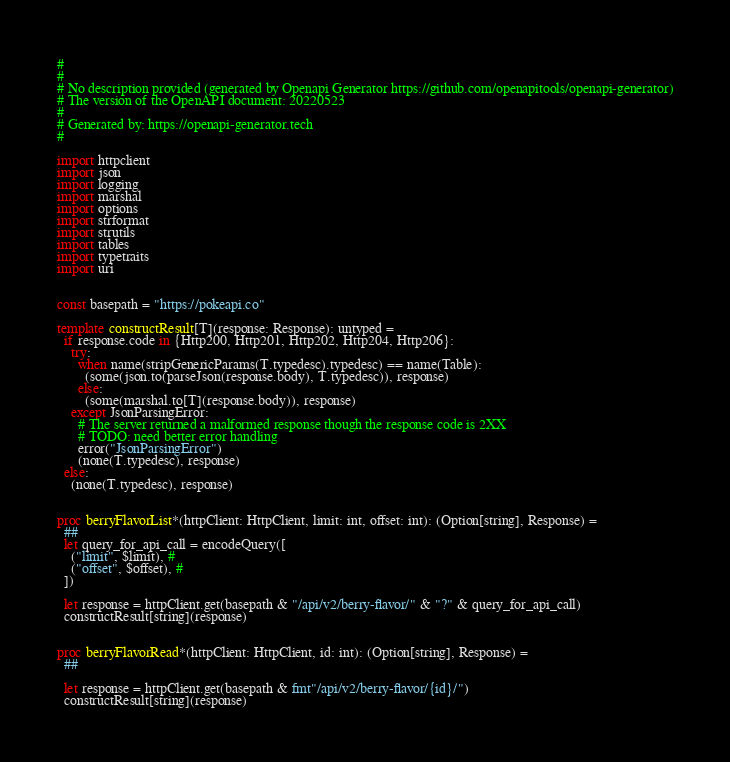Convert code to text. <code><loc_0><loc_0><loc_500><loc_500><_Nim_>#
# 
# No description provided (generated by Openapi Generator https://github.com/openapitools/openapi-generator)
# The version of the OpenAPI document: 20220523
# 
# Generated by: https://openapi-generator.tech
#

import httpclient
import json
import logging
import marshal
import options
import strformat
import strutils
import tables
import typetraits
import uri


const basepath = "https://pokeapi.co"

template constructResult[T](response: Response): untyped =
  if response.code in {Http200, Http201, Http202, Http204, Http206}:
    try:
      when name(stripGenericParams(T.typedesc).typedesc) == name(Table):
        (some(json.to(parseJson(response.body), T.typedesc)), response)
      else:
        (some(marshal.to[T](response.body)), response)
    except JsonParsingError:
      # The server returned a malformed response though the response code is 2XX
      # TODO: need better error handling
      error("JsonParsingError")
      (none(T.typedesc), response)
  else:
    (none(T.typedesc), response)


proc berryFlavorList*(httpClient: HttpClient, limit: int, offset: int): (Option[string], Response) =
  ## 
  let query_for_api_call = encodeQuery([
    ("limit", $limit), # 
    ("offset", $offset), # 
  ])

  let response = httpClient.get(basepath & "/api/v2/berry-flavor/" & "?" & query_for_api_call)
  constructResult[string](response)


proc berryFlavorRead*(httpClient: HttpClient, id: int): (Option[string], Response) =
  ## 

  let response = httpClient.get(basepath & fmt"/api/v2/berry-flavor/{id}/")
  constructResult[string](response)

</code> 